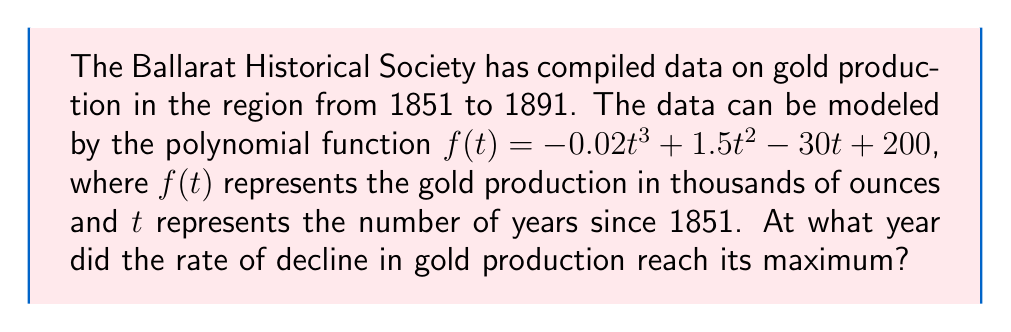Can you solve this math problem? To find the year when the rate of decline in gold production reached its maximum, we need to follow these steps:

1) The rate of change in gold production is given by the first derivative of $f(t)$:
   $$f'(t) = -0.06t^2 + 3t - 30$$

2) The rate of decline reaches its maximum when the second derivative equals zero:
   $$f''(t) = -0.12t + 3$$

3) Set $f''(t) = 0$ and solve for $t$:
   $$-0.12t + 3 = 0$$
   $$-0.12t = -3$$
   $$t = 25$$

4) This means the rate of decline reached its maximum 25 years after 1851.

5) To find the actual year, add 25 to 1851:
   1851 + 25 = 1876

Therefore, the rate of decline in gold production reached its maximum in 1876.
Answer: 1876 